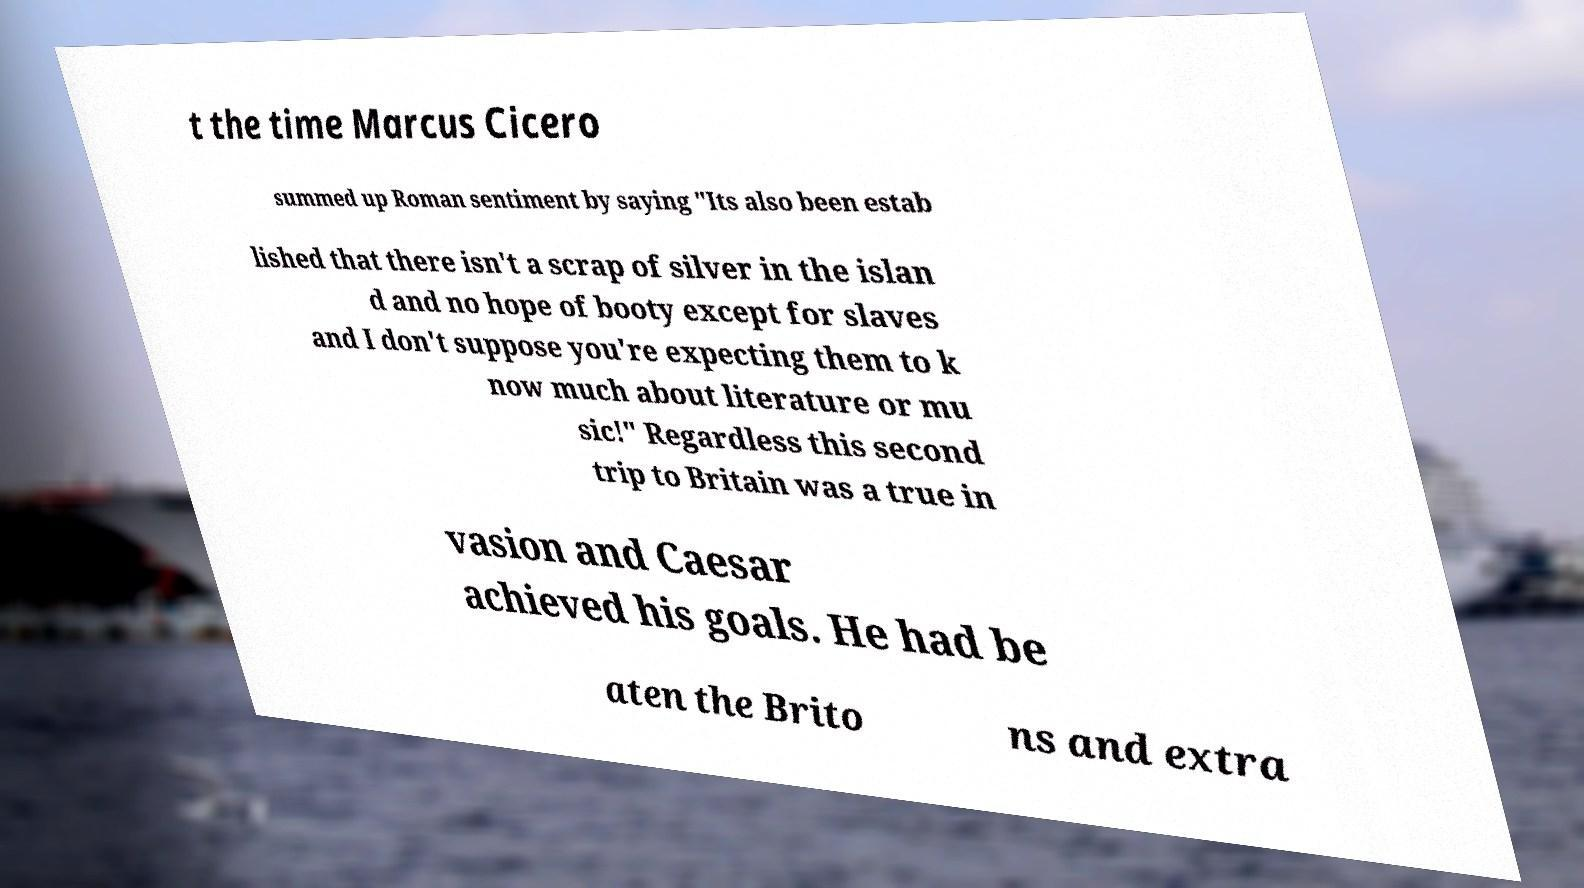Please read and relay the text visible in this image. What does it say? t the time Marcus Cicero summed up Roman sentiment by saying "Its also been estab lished that there isn't a scrap of silver in the islan d and no hope of booty except for slaves and I don't suppose you're expecting them to k now much about literature or mu sic!" Regardless this second trip to Britain was a true in vasion and Caesar achieved his goals. He had be aten the Brito ns and extra 